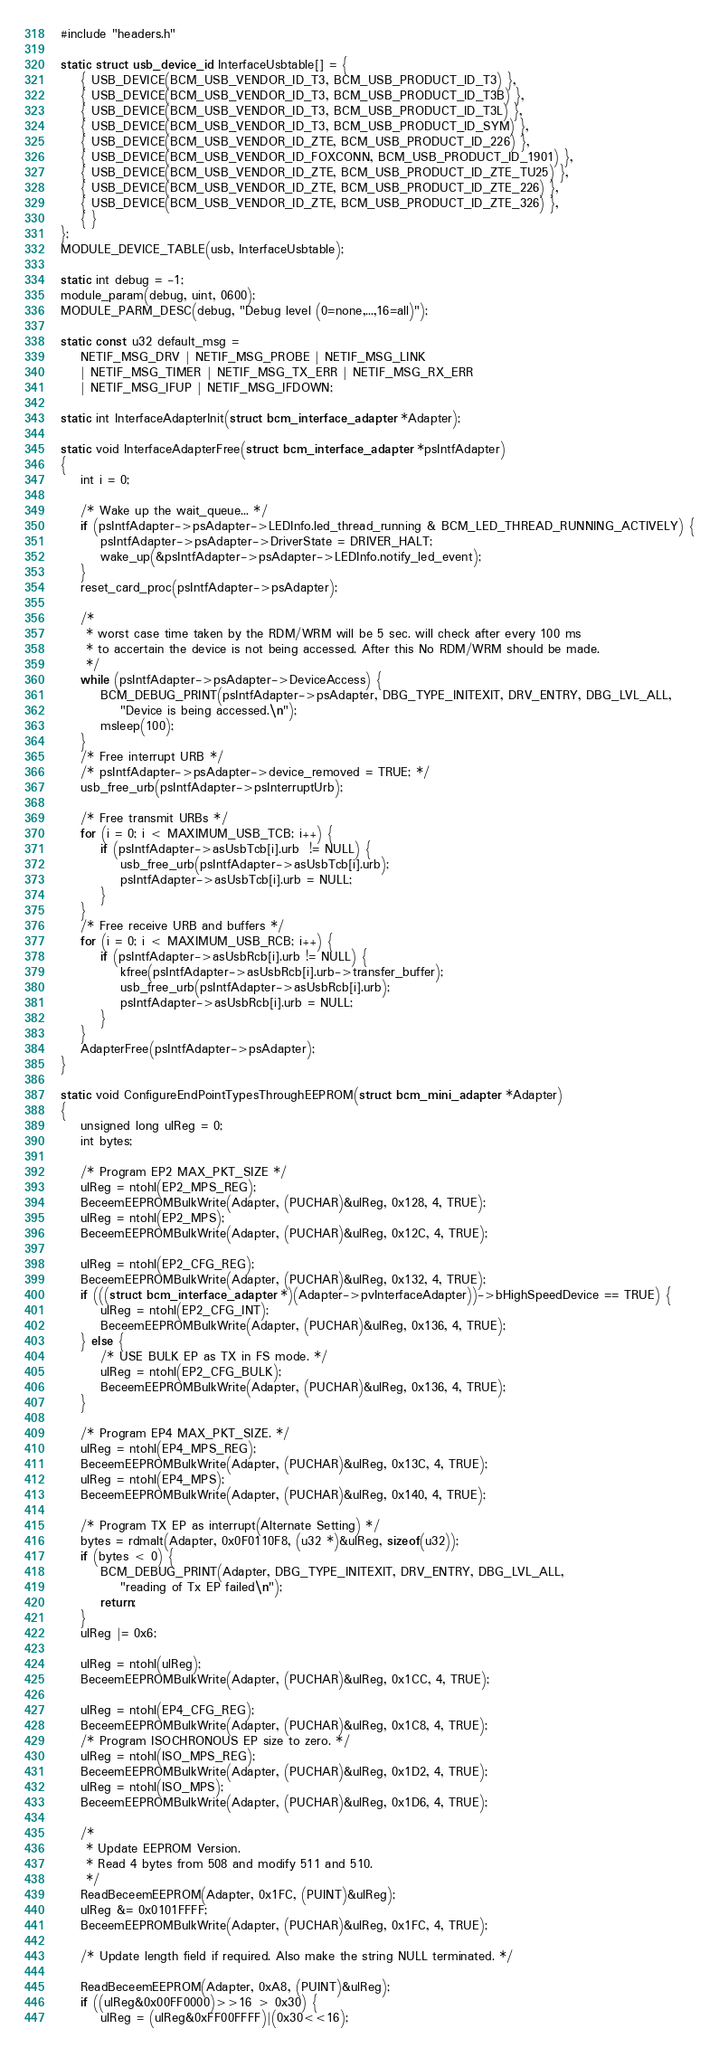<code> <loc_0><loc_0><loc_500><loc_500><_C_>#include "headers.h"

static struct usb_device_id InterfaceUsbtable[] = {
	{ USB_DEVICE(BCM_USB_VENDOR_ID_T3, BCM_USB_PRODUCT_ID_T3) },
	{ USB_DEVICE(BCM_USB_VENDOR_ID_T3, BCM_USB_PRODUCT_ID_T3B) },
	{ USB_DEVICE(BCM_USB_VENDOR_ID_T3, BCM_USB_PRODUCT_ID_T3L) },
	{ USB_DEVICE(BCM_USB_VENDOR_ID_T3, BCM_USB_PRODUCT_ID_SYM) },
	{ USB_DEVICE(BCM_USB_VENDOR_ID_ZTE, BCM_USB_PRODUCT_ID_226) },
	{ USB_DEVICE(BCM_USB_VENDOR_ID_FOXCONN, BCM_USB_PRODUCT_ID_1901) },
	{ USB_DEVICE(BCM_USB_VENDOR_ID_ZTE, BCM_USB_PRODUCT_ID_ZTE_TU25) },
	{ USB_DEVICE(BCM_USB_VENDOR_ID_ZTE, BCM_USB_PRODUCT_ID_ZTE_226) },
	{ USB_DEVICE(BCM_USB_VENDOR_ID_ZTE, BCM_USB_PRODUCT_ID_ZTE_326) },
	{ }
};
MODULE_DEVICE_TABLE(usb, InterfaceUsbtable);

static int debug = -1;
module_param(debug, uint, 0600);
MODULE_PARM_DESC(debug, "Debug level (0=none,...,16=all)");

static const u32 default_msg =
	NETIF_MSG_DRV | NETIF_MSG_PROBE | NETIF_MSG_LINK
	| NETIF_MSG_TIMER | NETIF_MSG_TX_ERR | NETIF_MSG_RX_ERR
	| NETIF_MSG_IFUP | NETIF_MSG_IFDOWN;

static int InterfaceAdapterInit(struct bcm_interface_adapter *Adapter);

static void InterfaceAdapterFree(struct bcm_interface_adapter *psIntfAdapter)
{
	int i = 0;

	/* Wake up the wait_queue... */
	if (psIntfAdapter->psAdapter->LEDInfo.led_thread_running & BCM_LED_THREAD_RUNNING_ACTIVELY) {
		psIntfAdapter->psAdapter->DriverState = DRIVER_HALT;
		wake_up(&psIntfAdapter->psAdapter->LEDInfo.notify_led_event);
	}
	reset_card_proc(psIntfAdapter->psAdapter);

	/*
	 * worst case time taken by the RDM/WRM will be 5 sec. will check after every 100 ms
	 * to accertain the device is not being accessed. After this No RDM/WRM should be made.
	 */
	while (psIntfAdapter->psAdapter->DeviceAccess) {
		BCM_DEBUG_PRINT(psIntfAdapter->psAdapter, DBG_TYPE_INITEXIT, DRV_ENTRY, DBG_LVL_ALL,
			"Device is being accessed.\n");
		msleep(100);
	}
	/* Free interrupt URB */
	/* psIntfAdapter->psAdapter->device_removed = TRUE; */
	usb_free_urb(psIntfAdapter->psInterruptUrb);

	/* Free transmit URBs */
	for (i = 0; i < MAXIMUM_USB_TCB; i++) {
		if (psIntfAdapter->asUsbTcb[i].urb  != NULL) {
			usb_free_urb(psIntfAdapter->asUsbTcb[i].urb);
			psIntfAdapter->asUsbTcb[i].urb = NULL;
		}
	}
	/* Free receive URB and buffers */
	for (i = 0; i < MAXIMUM_USB_RCB; i++) {
		if (psIntfAdapter->asUsbRcb[i].urb != NULL) {
			kfree(psIntfAdapter->asUsbRcb[i].urb->transfer_buffer);
			usb_free_urb(psIntfAdapter->asUsbRcb[i].urb);
			psIntfAdapter->asUsbRcb[i].urb = NULL;
		}
	}
	AdapterFree(psIntfAdapter->psAdapter);
}

static void ConfigureEndPointTypesThroughEEPROM(struct bcm_mini_adapter *Adapter)
{
	unsigned long ulReg = 0;
	int bytes;

	/* Program EP2 MAX_PKT_SIZE */
	ulReg = ntohl(EP2_MPS_REG);
	BeceemEEPROMBulkWrite(Adapter, (PUCHAR)&ulReg, 0x128, 4, TRUE);
	ulReg = ntohl(EP2_MPS);
	BeceemEEPROMBulkWrite(Adapter, (PUCHAR)&ulReg, 0x12C, 4, TRUE);

	ulReg = ntohl(EP2_CFG_REG);
	BeceemEEPROMBulkWrite(Adapter, (PUCHAR)&ulReg, 0x132, 4, TRUE);
	if (((struct bcm_interface_adapter *)(Adapter->pvInterfaceAdapter))->bHighSpeedDevice == TRUE) {
		ulReg = ntohl(EP2_CFG_INT);
		BeceemEEPROMBulkWrite(Adapter, (PUCHAR)&ulReg, 0x136, 4, TRUE);
	} else {
		/* USE BULK EP as TX in FS mode. */
		ulReg = ntohl(EP2_CFG_BULK);
		BeceemEEPROMBulkWrite(Adapter, (PUCHAR)&ulReg, 0x136, 4, TRUE);
	}

	/* Program EP4 MAX_PKT_SIZE. */
	ulReg = ntohl(EP4_MPS_REG);
	BeceemEEPROMBulkWrite(Adapter, (PUCHAR)&ulReg, 0x13C, 4, TRUE);
	ulReg = ntohl(EP4_MPS);
	BeceemEEPROMBulkWrite(Adapter, (PUCHAR)&ulReg, 0x140, 4, TRUE);

	/* Program TX EP as interrupt(Alternate Setting) */
	bytes = rdmalt(Adapter, 0x0F0110F8, (u32 *)&ulReg, sizeof(u32));
	if (bytes < 0) {
		BCM_DEBUG_PRINT(Adapter, DBG_TYPE_INITEXIT, DRV_ENTRY, DBG_LVL_ALL,
			"reading of Tx EP failed\n");
		return;
	}
	ulReg |= 0x6;

	ulReg = ntohl(ulReg);
	BeceemEEPROMBulkWrite(Adapter, (PUCHAR)&ulReg, 0x1CC, 4, TRUE);

	ulReg = ntohl(EP4_CFG_REG);
	BeceemEEPROMBulkWrite(Adapter, (PUCHAR)&ulReg, 0x1C8, 4, TRUE);
	/* Program ISOCHRONOUS EP size to zero. */
	ulReg = ntohl(ISO_MPS_REG);
	BeceemEEPROMBulkWrite(Adapter, (PUCHAR)&ulReg, 0x1D2, 4, TRUE);
	ulReg = ntohl(ISO_MPS);
	BeceemEEPROMBulkWrite(Adapter, (PUCHAR)&ulReg, 0x1D6, 4, TRUE);

	/*
	 * Update EEPROM Version.
	 * Read 4 bytes from 508 and modify 511 and 510.
	 */
	ReadBeceemEEPROM(Adapter, 0x1FC, (PUINT)&ulReg);
	ulReg &= 0x0101FFFF;
	BeceemEEPROMBulkWrite(Adapter, (PUCHAR)&ulReg, 0x1FC, 4, TRUE);

	/* Update length field if required. Also make the string NULL terminated. */

	ReadBeceemEEPROM(Adapter, 0xA8, (PUINT)&ulReg);
	if ((ulReg&0x00FF0000)>>16 > 0x30) {
		ulReg = (ulReg&0xFF00FFFF)|(0x30<<16);</code> 